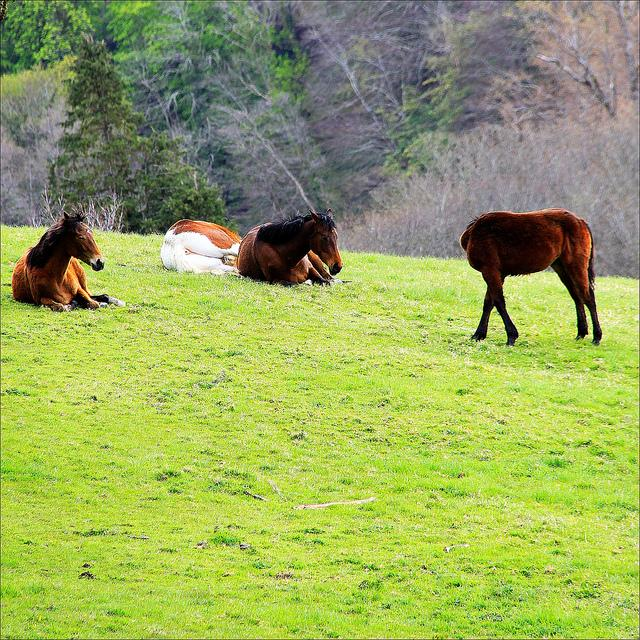Which of these horses would stand out in a dark setting? white horse 